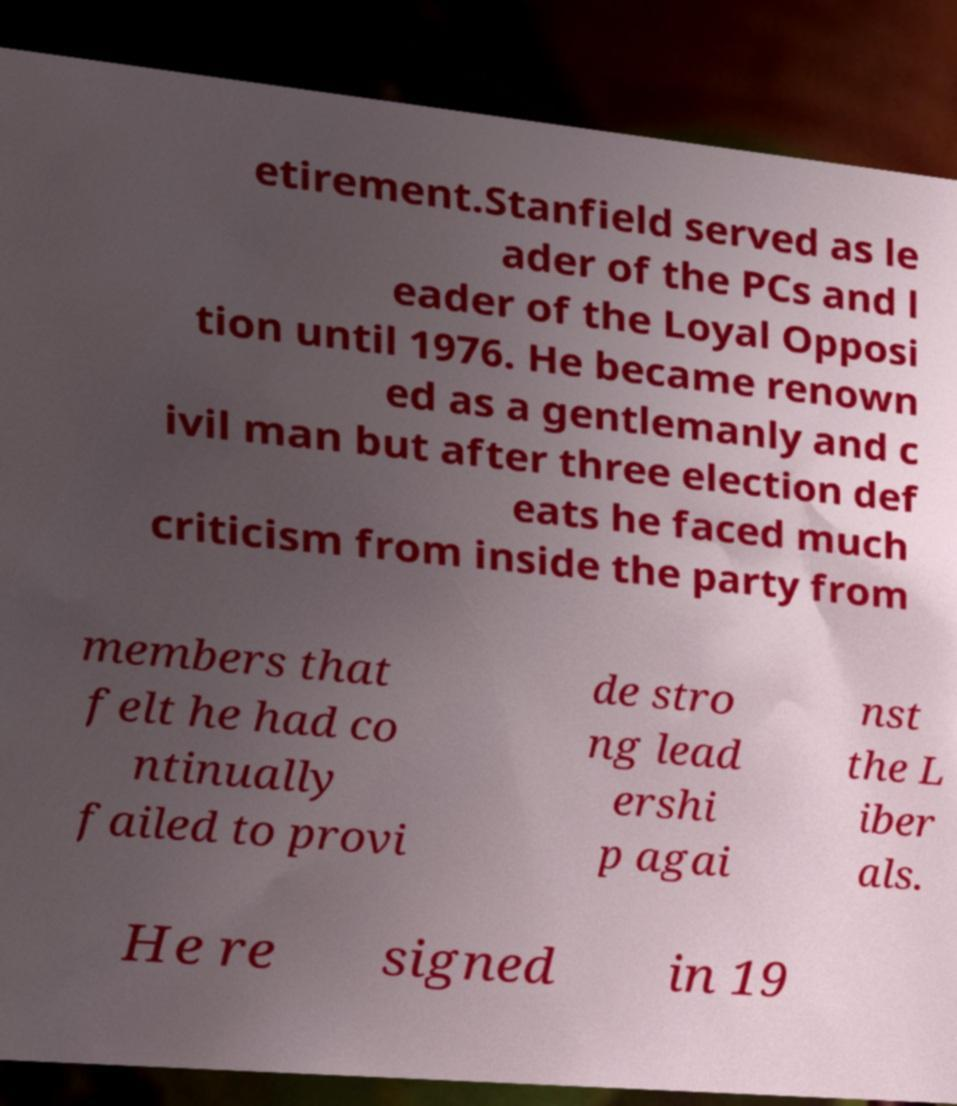There's text embedded in this image that I need extracted. Can you transcribe it verbatim? etirement.Stanfield served as le ader of the PCs and l eader of the Loyal Opposi tion until 1976. He became renown ed as a gentlemanly and c ivil man but after three election def eats he faced much criticism from inside the party from members that felt he had co ntinually failed to provi de stro ng lead ershi p agai nst the L iber als. He re signed in 19 